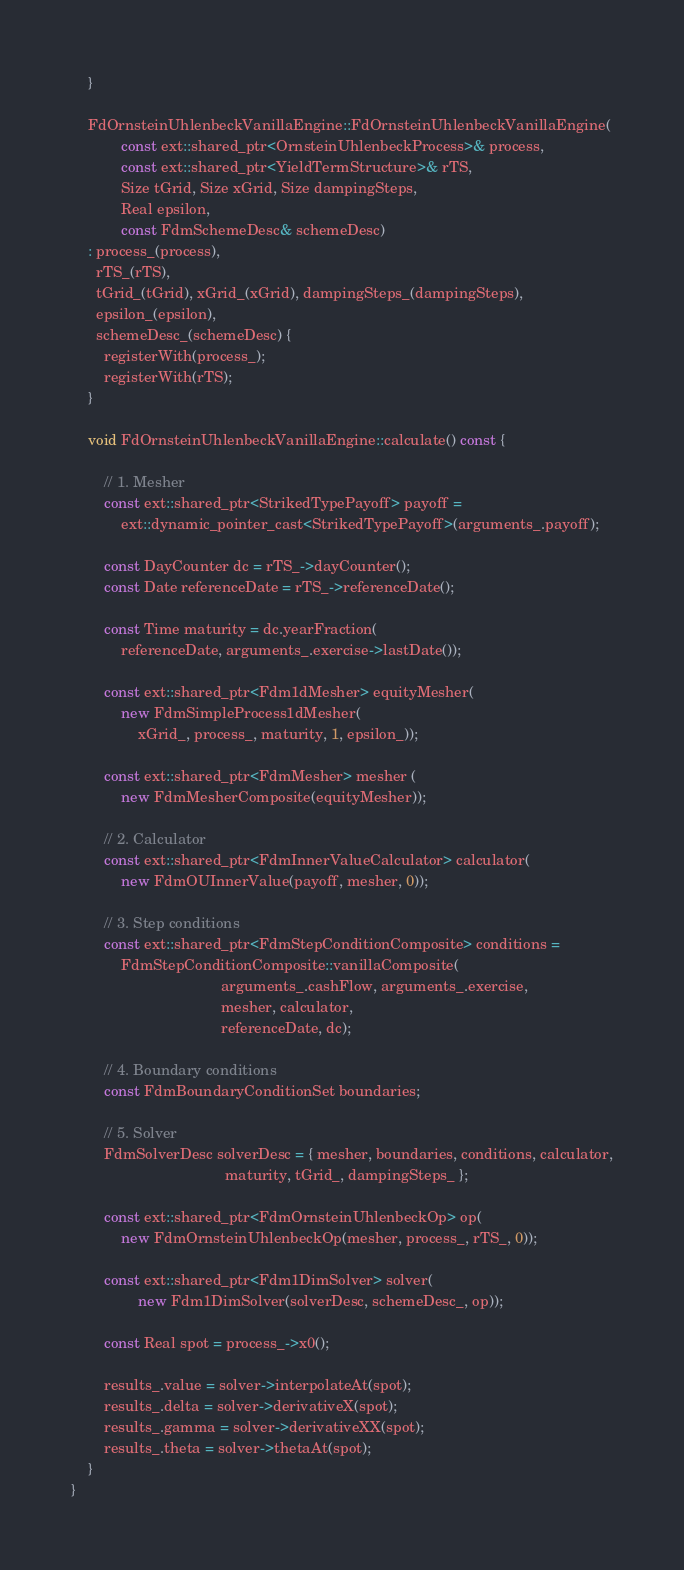Convert code to text. <code><loc_0><loc_0><loc_500><loc_500><_C++_>    }

    FdOrnsteinUhlenbeckVanillaEngine::FdOrnsteinUhlenbeckVanillaEngine(
            const ext::shared_ptr<OrnsteinUhlenbeckProcess>& process,
            const ext::shared_ptr<YieldTermStructure>& rTS,
            Size tGrid, Size xGrid, Size dampingSteps,
            Real epsilon,
            const FdmSchemeDesc& schemeDesc)
    : process_(process),
      rTS_(rTS),
      tGrid_(tGrid), xGrid_(xGrid), dampingSteps_(dampingSteps),
      epsilon_(epsilon),
      schemeDesc_(schemeDesc) {
        registerWith(process_);
        registerWith(rTS);
    }

    void FdOrnsteinUhlenbeckVanillaEngine::calculate() const {

        // 1. Mesher
        const ext::shared_ptr<StrikedTypePayoff> payoff =
            ext::dynamic_pointer_cast<StrikedTypePayoff>(arguments_.payoff);

        const DayCounter dc = rTS_->dayCounter();
        const Date referenceDate = rTS_->referenceDate();

        const Time maturity = dc.yearFraction(
            referenceDate, arguments_.exercise->lastDate());

        const ext::shared_ptr<Fdm1dMesher> equityMesher(
            new FdmSimpleProcess1dMesher(
                xGrid_, process_, maturity, 1, epsilon_));

        const ext::shared_ptr<FdmMesher> mesher (
            new FdmMesherComposite(equityMesher));

        // 2. Calculator
        const ext::shared_ptr<FdmInnerValueCalculator> calculator(
            new FdmOUInnerValue(payoff, mesher, 0));

        // 3. Step conditions
        const ext::shared_ptr<FdmStepConditionComposite> conditions =
            FdmStepConditionComposite::vanillaComposite(
                                    arguments_.cashFlow, arguments_.exercise,
                                    mesher, calculator,
                                    referenceDate, dc);

        // 4. Boundary conditions
        const FdmBoundaryConditionSet boundaries;

        // 5. Solver
        FdmSolverDesc solverDesc = { mesher, boundaries, conditions, calculator,
                                     maturity, tGrid_, dampingSteps_ };

        const ext::shared_ptr<FdmOrnsteinUhlenbeckOp> op(
            new FdmOrnsteinUhlenbeckOp(mesher, process_, rTS_, 0));

        const ext::shared_ptr<Fdm1DimSolver> solver(
                new Fdm1DimSolver(solverDesc, schemeDesc_, op));

        const Real spot = process_->x0();

        results_.value = solver->interpolateAt(spot);
        results_.delta = solver->derivativeX(spot);
        results_.gamma = solver->derivativeXX(spot);
        results_.theta = solver->thetaAt(spot);
    }
}
</code> 